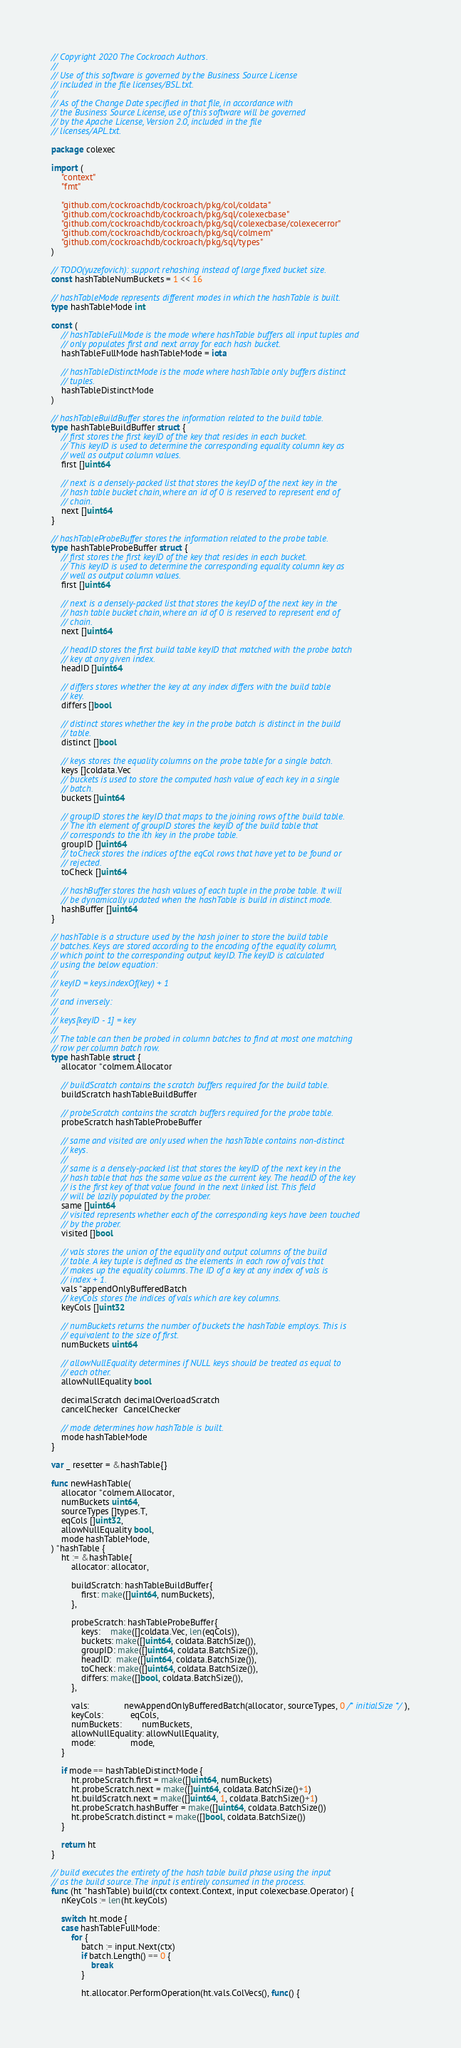<code> <loc_0><loc_0><loc_500><loc_500><_Go_>// Copyright 2020 The Cockroach Authors.
//
// Use of this software is governed by the Business Source License
// included in the file licenses/BSL.txt.
//
// As of the Change Date specified in that file, in accordance with
// the Business Source License, use of this software will be governed
// by the Apache License, Version 2.0, included in the file
// licenses/APL.txt.

package colexec

import (
	"context"
	"fmt"

	"github.com/cockroachdb/cockroach/pkg/col/coldata"
	"github.com/cockroachdb/cockroach/pkg/sql/colexecbase"
	"github.com/cockroachdb/cockroach/pkg/sql/colexecbase/colexecerror"
	"github.com/cockroachdb/cockroach/pkg/sql/colmem"
	"github.com/cockroachdb/cockroach/pkg/sql/types"
)

// TODO(yuzefovich): support rehashing instead of large fixed bucket size.
const hashTableNumBuckets = 1 << 16

// hashTableMode represents different modes in which the hashTable is built.
type hashTableMode int

const (
	// hashTableFullMode is the mode where hashTable buffers all input tuples and
	// only populates first and next array for each hash bucket.
	hashTableFullMode hashTableMode = iota

	// hashTableDistinctMode is the mode where hashTable only buffers distinct
	// tuples.
	hashTableDistinctMode
)

// hashTableBuildBuffer stores the information related to the build table.
type hashTableBuildBuffer struct {
	// first stores the first keyID of the key that resides in each bucket.
	// This keyID is used to determine the corresponding equality column key as
	// well as output column values.
	first []uint64

	// next is a densely-packed list that stores the keyID of the next key in the
	// hash table bucket chain, where an id of 0 is reserved to represent end of
	// chain.
	next []uint64
}

// hashTableProbeBuffer stores the information related to the probe table.
type hashTableProbeBuffer struct {
	// first stores the first keyID of the key that resides in each bucket.
	// This keyID is used to determine the corresponding equality column key as
	// well as output column values.
	first []uint64

	// next is a densely-packed list that stores the keyID of the next key in the
	// hash table bucket chain, where an id of 0 is reserved to represent end of
	// chain.
	next []uint64

	// headID stores the first build table keyID that matched with the probe batch
	// key at any given index.
	headID []uint64

	// differs stores whether the key at any index differs with the build table
	// key.
	differs []bool

	// distinct stores whether the key in the probe batch is distinct in the build
	// table.
	distinct []bool

	// keys stores the equality columns on the probe table for a single batch.
	keys []coldata.Vec
	// buckets is used to store the computed hash value of each key in a single
	// batch.
	buckets []uint64

	// groupID stores the keyID that maps to the joining rows of the build table.
	// The ith element of groupID stores the keyID of the build table that
	// corresponds to the ith key in the probe table.
	groupID []uint64
	// toCheck stores the indices of the eqCol rows that have yet to be found or
	// rejected.
	toCheck []uint64

	// hashBuffer stores the hash values of each tuple in the probe table. It will
	// be dynamically updated when the hashTable is build in distinct mode.
	hashBuffer []uint64
}

// hashTable is a structure used by the hash joiner to store the build table
// batches. Keys are stored according to the encoding of the equality column,
// which point to the corresponding output keyID. The keyID is calculated
// using the below equation:
//
// keyID = keys.indexOf(key) + 1
//
// and inversely:
//
// keys[keyID - 1] = key
//
// The table can then be probed in column batches to find at most one matching
// row per column batch row.
type hashTable struct {
	allocator *colmem.Allocator

	// buildScratch contains the scratch buffers required for the build table.
	buildScratch hashTableBuildBuffer

	// probeScratch contains the scratch buffers required for the probe table.
	probeScratch hashTableProbeBuffer

	// same and visited are only used when the hashTable contains non-distinct
	// keys.
	//
	// same is a densely-packed list that stores the keyID of the next key in the
	// hash table that has the same value as the current key. The headID of the key
	// is the first key of that value found in the next linked list. This field
	// will be lazily populated by the prober.
	same []uint64
	// visited represents whether each of the corresponding keys have been touched
	// by the prober.
	visited []bool

	// vals stores the union of the equality and output columns of the build
	// table. A key tuple is defined as the elements in each row of vals that
	// makes up the equality columns. The ID of a key at any index of vals is
	// index + 1.
	vals *appendOnlyBufferedBatch
	// keyCols stores the indices of vals which are key columns.
	keyCols []uint32

	// numBuckets returns the number of buckets the hashTable employs. This is
	// equivalent to the size of first.
	numBuckets uint64

	// allowNullEquality determines if NULL keys should be treated as equal to
	// each other.
	allowNullEquality bool

	decimalScratch decimalOverloadScratch
	cancelChecker  CancelChecker

	// mode determines how hashTable is built.
	mode hashTableMode
}

var _ resetter = &hashTable{}

func newHashTable(
	allocator *colmem.Allocator,
	numBuckets uint64,
	sourceTypes []types.T,
	eqCols []uint32,
	allowNullEquality bool,
	mode hashTableMode,
) *hashTable {
	ht := &hashTable{
		allocator: allocator,

		buildScratch: hashTableBuildBuffer{
			first: make([]uint64, numBuckets),
		},

		probeScratch: hashTableProbeBuffer{
			keys:    make([]coldata.Vec, len(eqCols)),
			buckets: make([]uint64, coldata.BatchSize()),
			groupID: make([]uint64, coldata.BatchSize()),
			headID:  make([]uint64, coldata.BatchSize()),
			toCheck: make([]uint64, coldata.BatchSize()),
			differs: make([]bool, coldata.BatchSize()),
		},

		vals:              newAppendOnlyBufferedBatch(allocator, sourceTypes, 0 /* initialSize */),
		keyCols:           eqCols,
		numBuckets:        numBuckets,
		allowNullEquality: allowNullEquality,
		mode:              mode,
	}

	if mode == hashTableDistinctMode {
		ht.probeScratch.first = make([]uint64, numBuckets)
		ht.probeScratch.next = make([]uint64, coldata.BatchSize()+1)
		ht.buildScratch.next = make([]uint64, 1, coldata.BatchSize()+1)
		ht.probeScratch.hashBuffer = make([]uint64, coldata.BatchSize())
		ht.probeScratch.distinct = make([]bool, coldata.BatchSize())
	}

	return ht
}

// build executes the entirety of the hash table build phase using the input
// as the build source. The input is entirely consumed in the process.
func (ht *hashTable) build(ctx context.Context, input colexecbase.Operator) {
	nKeyCols := len(ht.keyCols)

	switch ht.mode {
	case hashTableFullMode:
		for {
			batch := input.Next(ctx)
			if batch.Length() == 0 {
				break
			}

			ht.allocator.PerformOperation(ht.vals.ColVecs(), func() {</code> 